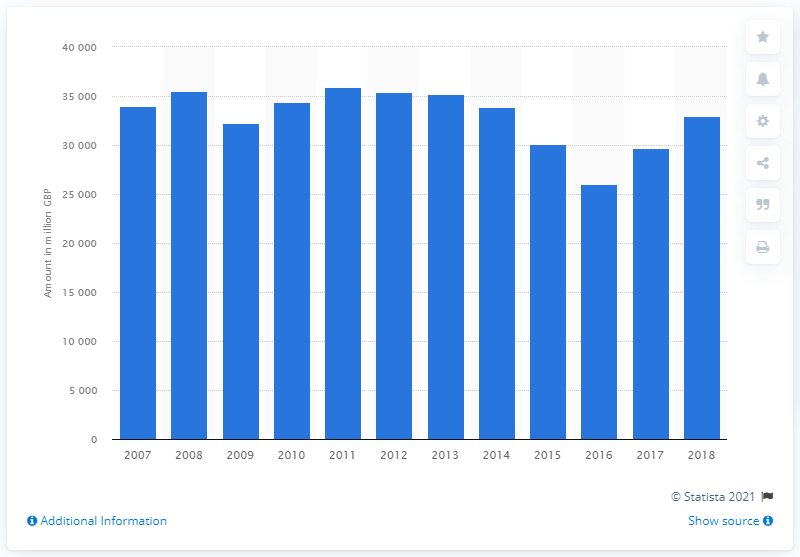List a handful of essential elements in this visual. In 2018, the total net written premiums of the general business insurance market in the UK were 32,929. 